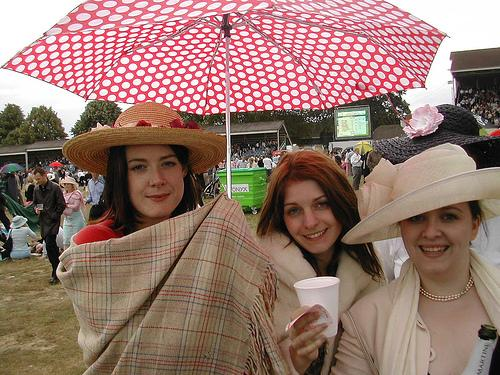Please describe the primary subjects of the photograph, along with their notable features. The image features three smiling women under a red umbrella with white dots, wearing attractive hats and one holding a white styrofoam cup. Describe the principal subjects in the image and their notable actions. Three ladies enjoy each other's company under a red, white-spotted umbrella, sporting fashionable hats and one cradling a white styrofoam cup. Tell us what is occurring in the photograph and make note of any eye-catching elements. In the photograph, three happy women stand beneath a red, spotted umbrella, wearing eye-catching hats, and one holds a white styrofoam cup. What is an accurate but brief depiction of the key aspects in the photo? Three joyous women huddle under a polka dot umbrella, donning trendy hats and one carrying a white styrofoam cup. Present the core event of the image, highlighting any standout items. Three grinning women gather under a red umbrella with white polka dots, wearing attention-grabbing hats and one clutching a white cup. What is the central focus of the image and what items draw attention? The central focus is three women standing under a red polka dot umbrella, wearing fashionable hats and one holding a white styrofoam cup. Mention the primary event taking place in the image and its key elements. Three women are having fun under a red umbrella with white dots in a crowded park, wearing stylish hats, and one holding a styrofoam cup. Briefly explain the main situation captured in the picture and any objects that are relevant. Three happy ladies are standing under a red and white umbrella, wearing elegant hats and one clutching a styrofoam cup. What is a concise yet detailed description of the image's main components? The picture portrays three cheerful women sheltering under a red umbrella with white spots, adorned in chic hats, and one holding a styrofoam cup. Summarize the main elements and actions taking place in the image. Three women smile beneath a polka dot umbrella and showcase stylish hats, while one grasps a white styrofoam cup. 